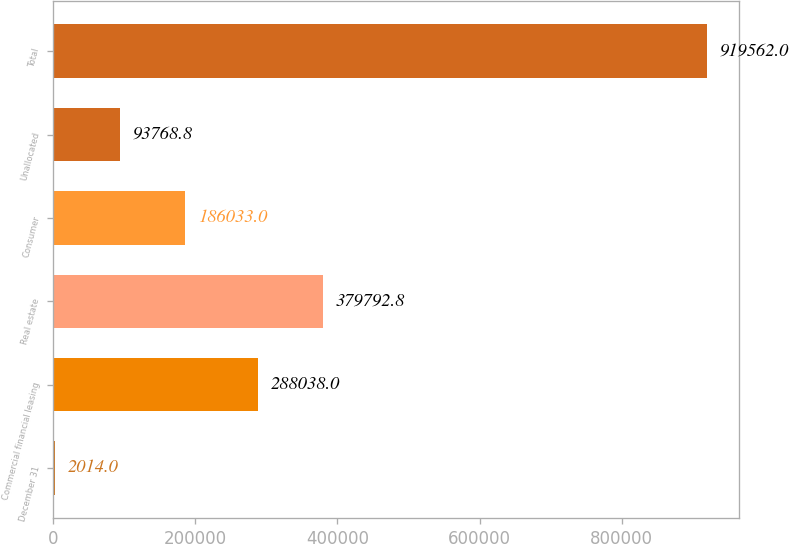Convert chart to OTSL. <chart><loc_0><loc_0><loc_500><loc_500><bar_chart><fcel>December 31<fcel>Commercial financial leasing<fcel>Real estate<fcel>Consumer<fcel>Unallocated<fcel>Total<nl><fcel>2014<fcel>288038<fcel>379793<fcel>186033<fcel>93768.8<fcel>919562<nl></chart> 